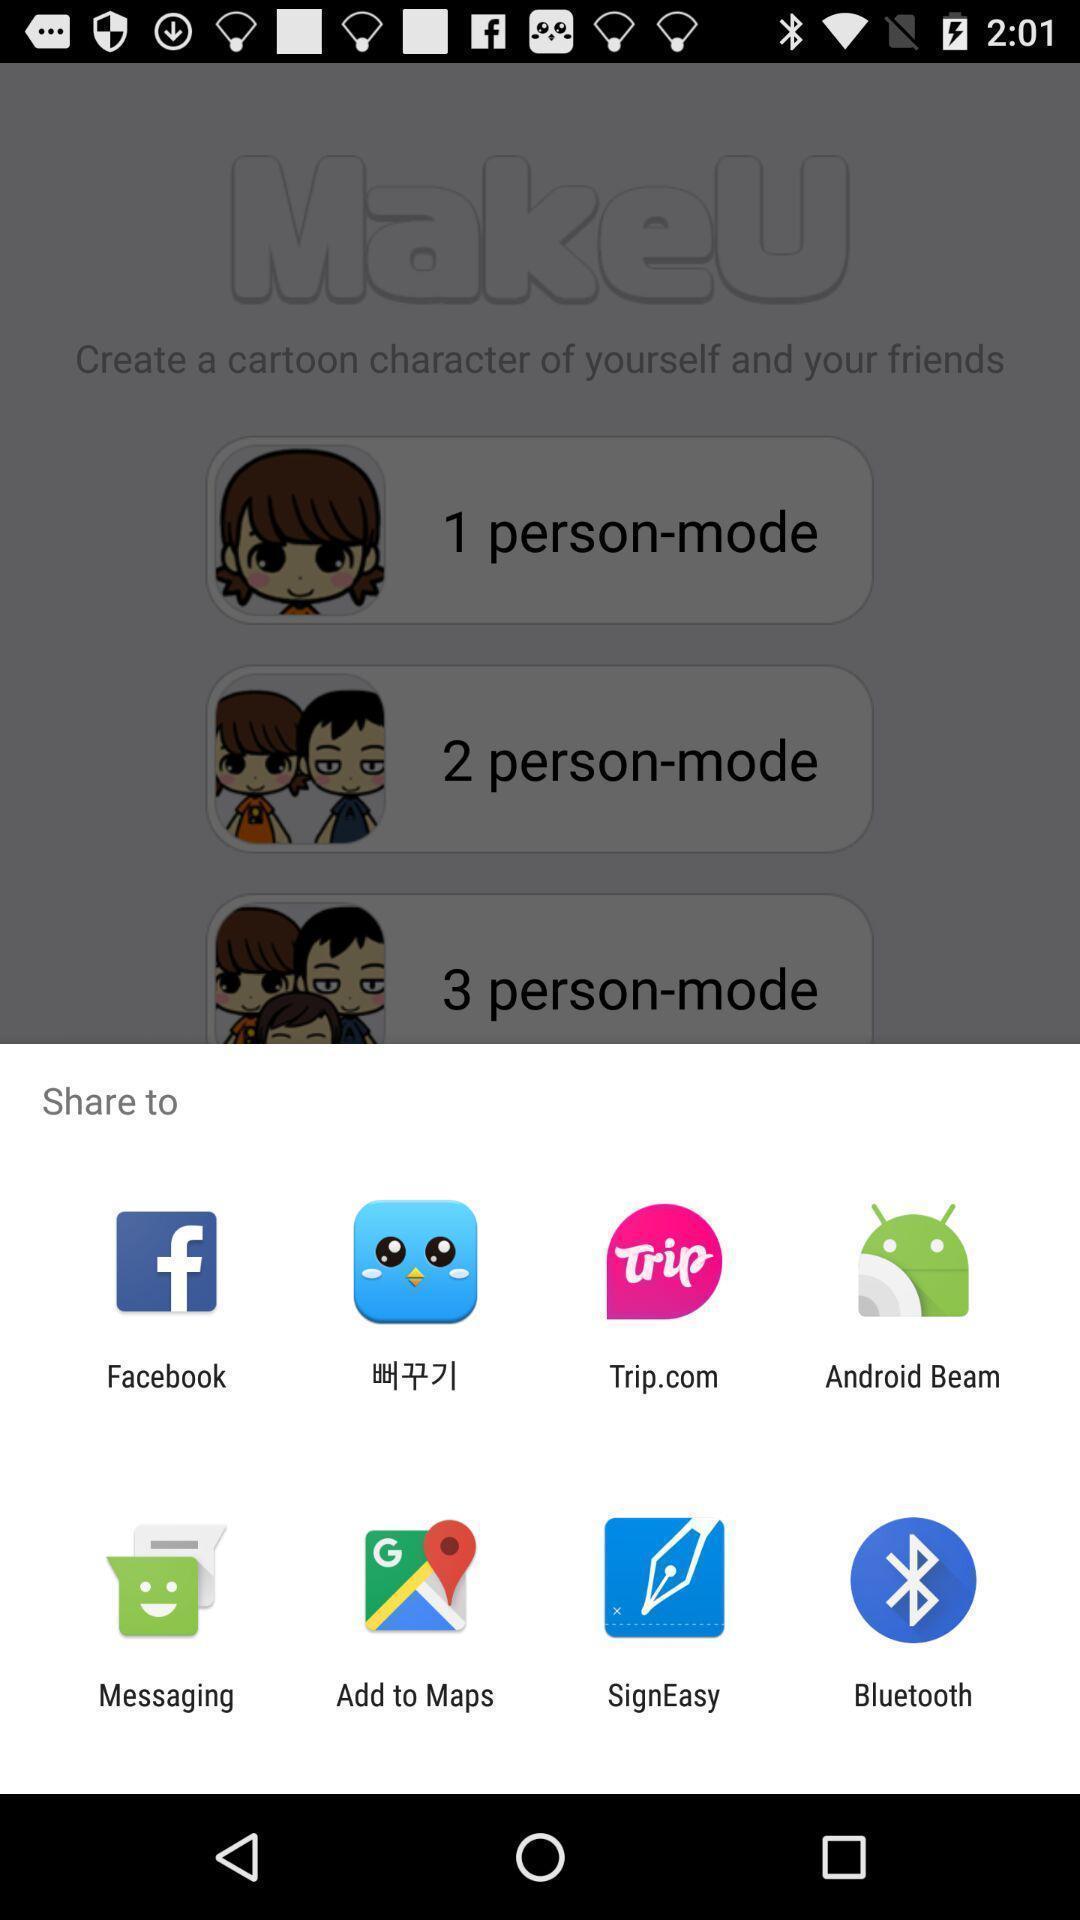Summarize the information in this screenshot. Pop-up shows share option with multiple applications. 